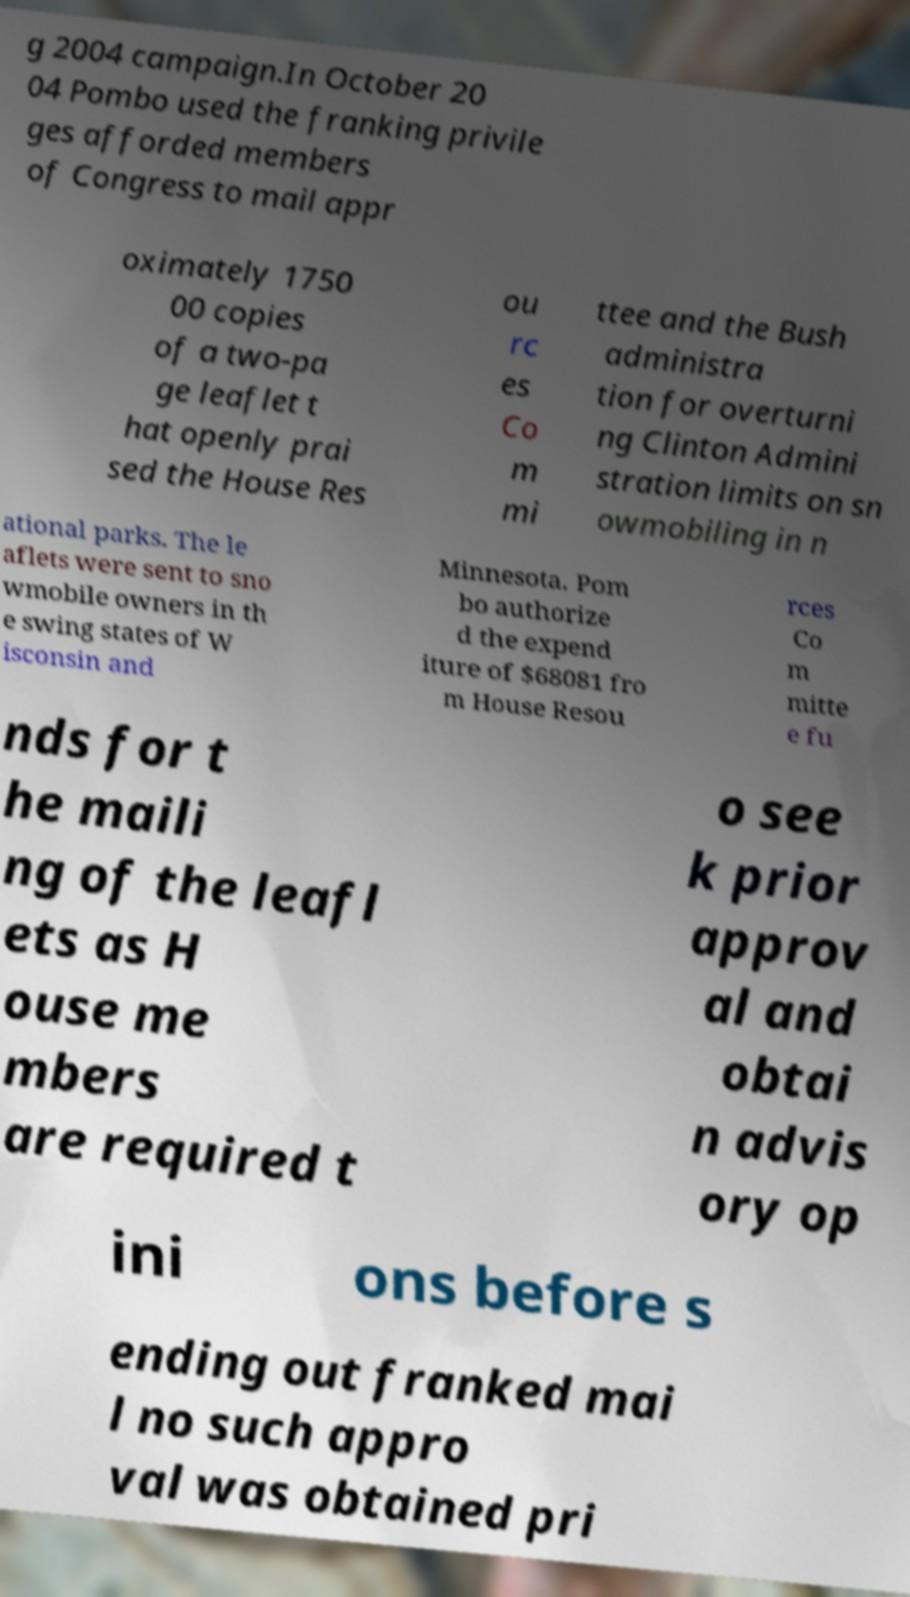Could you extract and type out the text from this image? g 2004 campaign.In October 20 04 Pombo used the franking privile ges afforded members of Congress to mail appr oximately 1750 00 copies of a two-pa ge leaflet t hat openly prai sed the House Res ou rc es Co m mi ttee and the Bush administra tion for overturni ng Clinton Admini stration limits on sn owmobiling in n ational parks. The le aflets were sent to sno wmobile owners in th e swing states of W isconsin and Minnesota. Pom bo authorize d the expend iture of $68081 fro m House Resou rces Co m mitte e fu nds for t he maili ng of the leafl ets as H ouse me mbers are required t o see k prior approv al and obtai n advis ory op ini ons before s ending out franked mai l no such appro val was obtained pri 